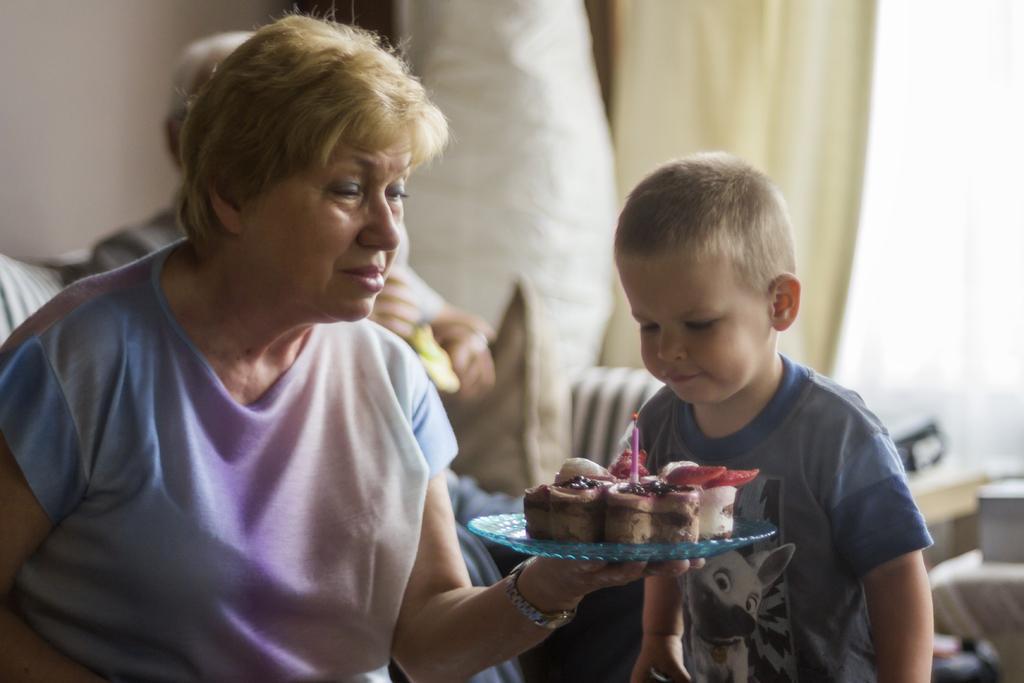In one or two sentences, can you explain what this image depicts? In this picture we can see a woman sitting and holding a plate with cake and candle, in front of her there is a boy standing, behind her we can see a person, pillows and sofa. In the background of the image it is blurry and we can see wall and curtain. 